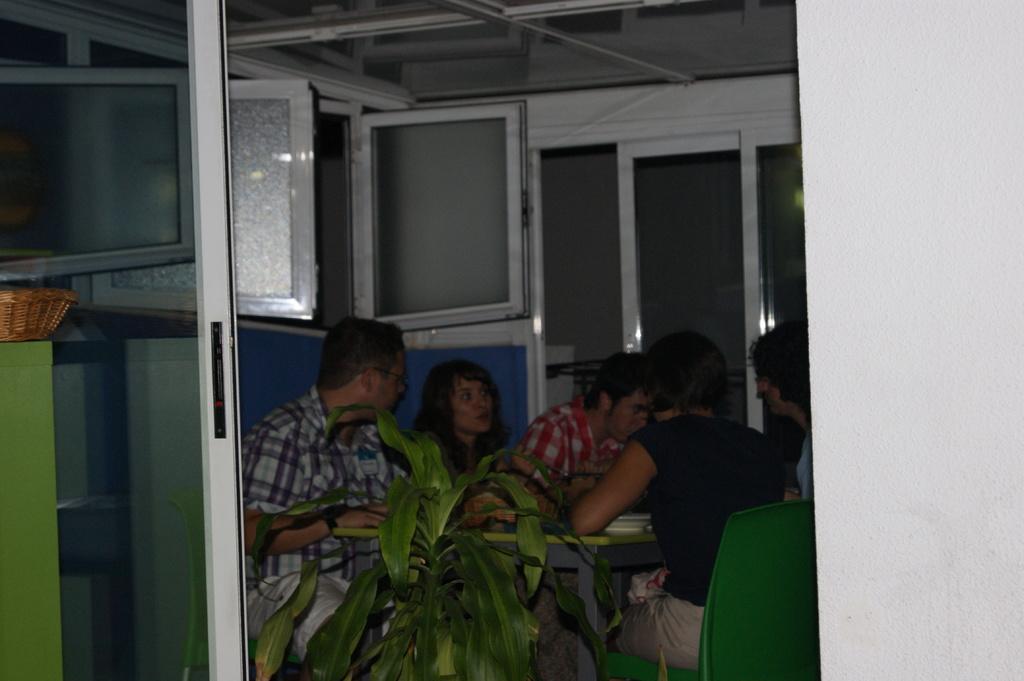In one or two sentences, can you explain what this image depicts? On the background we can see windows and doors. Here we can see few persons sitting on chairs in front of a table and on the table we can see a plate. This is a plant. Here we can see basket. 